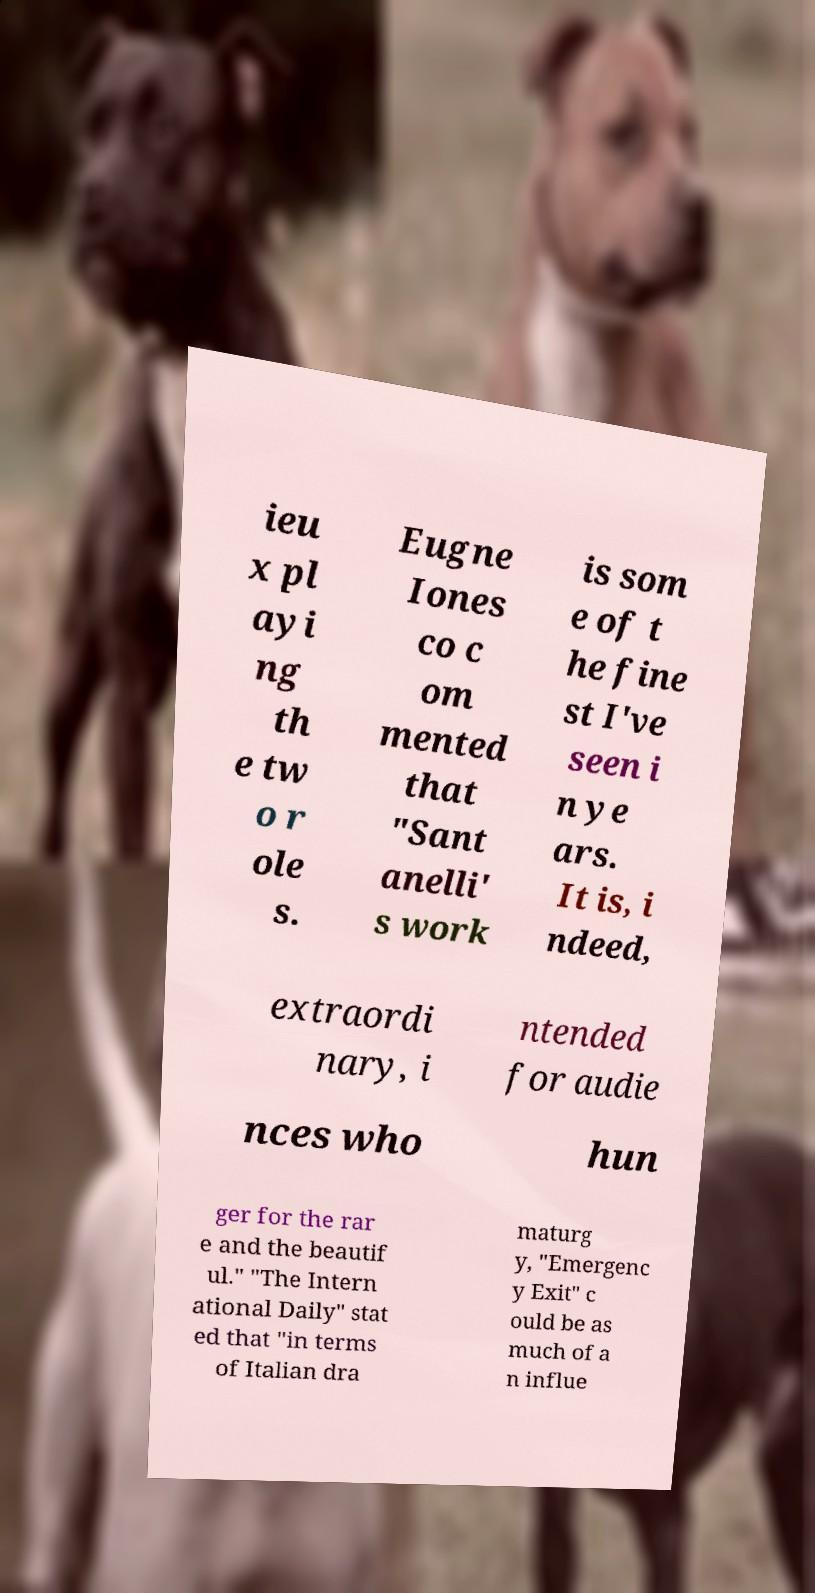Could you assist in decoding the text presented in this image and type it out clearly? ieu x pl ayi ng th e tw o r ole s. Eugne Iones co c om mented that "Sant anelli' s work is som e of t he fine st I've seen i n ye ars. It is, i ndeed, extraordi nary, i ntended for audie nces who hun ger for the rar e and the beautif ul." "The Intern ational Daily" stat ed that "in terms of Italian dra maturg y, "Emergenc y Exit" c ould be as much of a n influe 